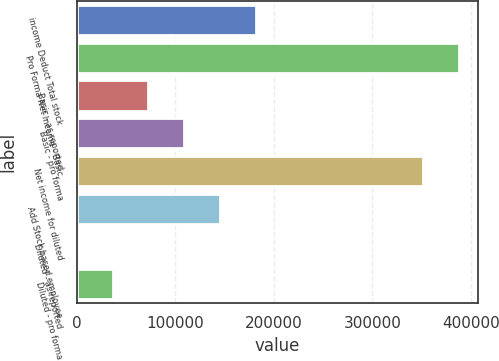<chart> <loc_0><loc_0><loc_500><loc_500><bar_chart><fcel>income Deduct Total stock<fcel>Pro Forma Net Income - Basic<fcel>Basic - as reported<fcel>Basic - pro forma<fcel>Net income for diluted<fcel>Add Stock based employee<fcel>Diluted - as reported<fcel>Diluted - pro forma<nl><fcel>181516<fcel>388293<fcel>72607.2<fcel>108910<fcel>351990<fcel>145213<fcel>1.52<fcel>36304.4<nl></chart> 